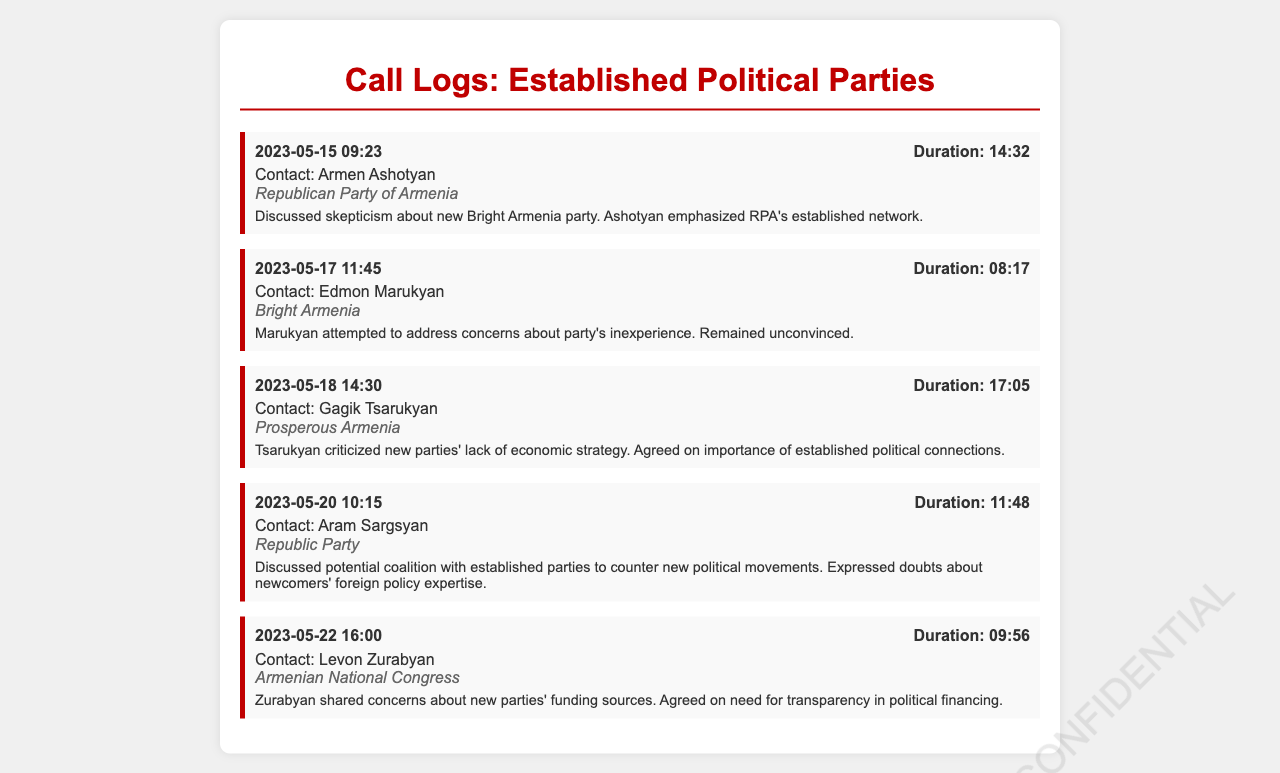what is the date of the call with Armen Ashotyan? The date of the call with Armen Ashotyan is specified in the call log.
Answer: 2023-05-15 how long was the call with Edmon Marukyan? The duration of the call with Edmon Marukyan is indicated in the log details.
Answer: 08:17 which political party does Gagik Tsarukyan represent? The party that Gagik Tsarukyan represents is noted clearly in the records.
Answer: Prosperous Armenia what concern did Levon Zurabyan share regarding new parties? The document mentions the specific concern Levon Zurabyan expressed in his conversation.
Answer: Funding sources who was skeptical about the new Bright Armenia party? The documented call notes identify who expressed skepticism about this party.
Answer: Armen Ashotyan why did Aram Sargsyan discuss potential coalition? This discussion is rooted in the context of countering specific political movements mentioned in the call log.
Answer: New political movements which party was mentioned in relation to economic strategy? The associated party is stated in the conversation with Gagik Tsarukyan.
Answer: Prosperous Armenia 